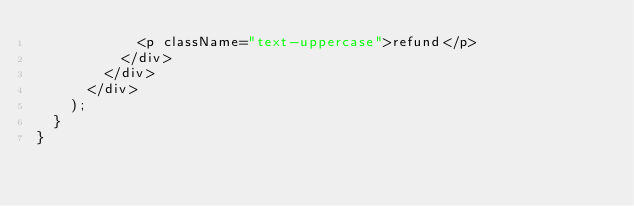<code> <loc_0><loc_0><loc_500><loc_500><_JavaScript_>            <p className="text-uppercase">refund</p>
          </div>
        </div>
      </div>
    );
  }
}
</code> 